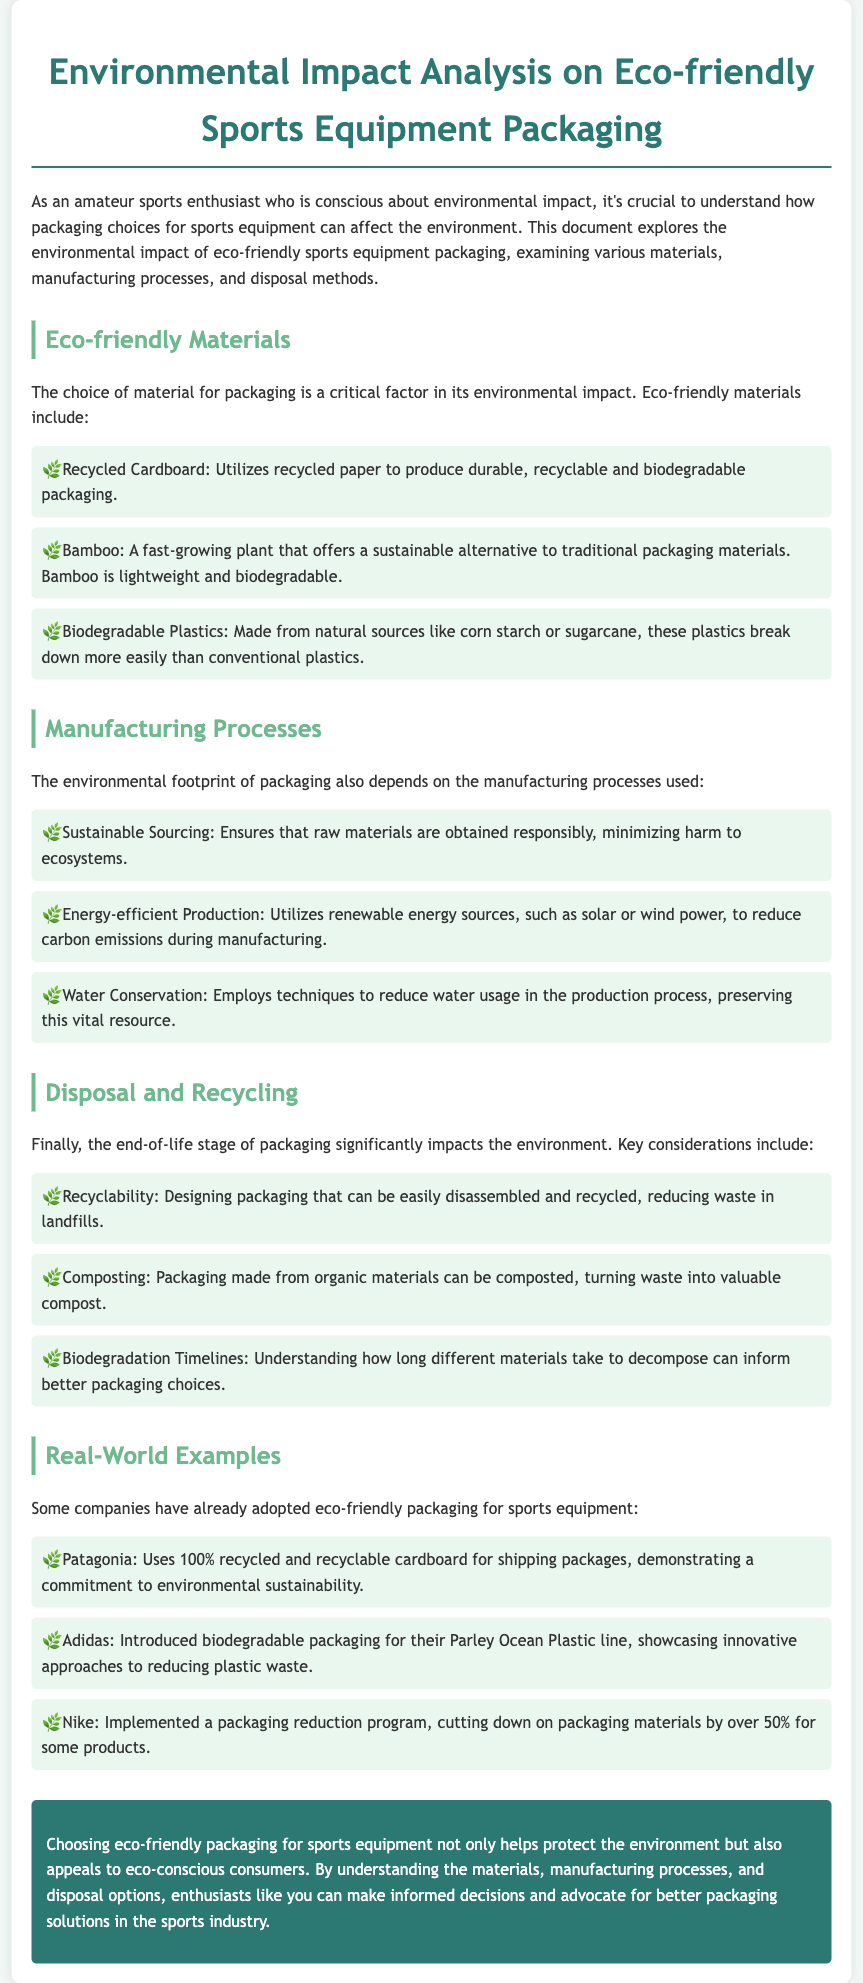What are eco-friendly materials mentioned? The document lists eco-friendly materials for sports equipment packaging, including Recycled Cardboard, Bamboo, and Biodegradable Plastics.
Answer: Recycled Cardboard, Bamboo, Biodegradable Plastics Which company uses 100% recycled cardboard? The document provides an example of Patagonia, which utilizes 100% recycled and recyclable cardboard for shipping packages.
Answer: Patagonia What manufacturing process minimizes harm to ecosystems? The environmental analysis refers to Sustainable Sourcing as a manufacturing process that minimizes harm to ecosystems.
Answer: Sustainable Sourcing How can organic packaging be disposed of? The document indicates that packaging made from organic materials can be composted, turning waste into valuable compost.
Answer: Composting What is one key factor that affects packaging's environmental impact? The document states that the choice of material for packaging is a critical factor in its environmental impact.
Answer: Material choice 